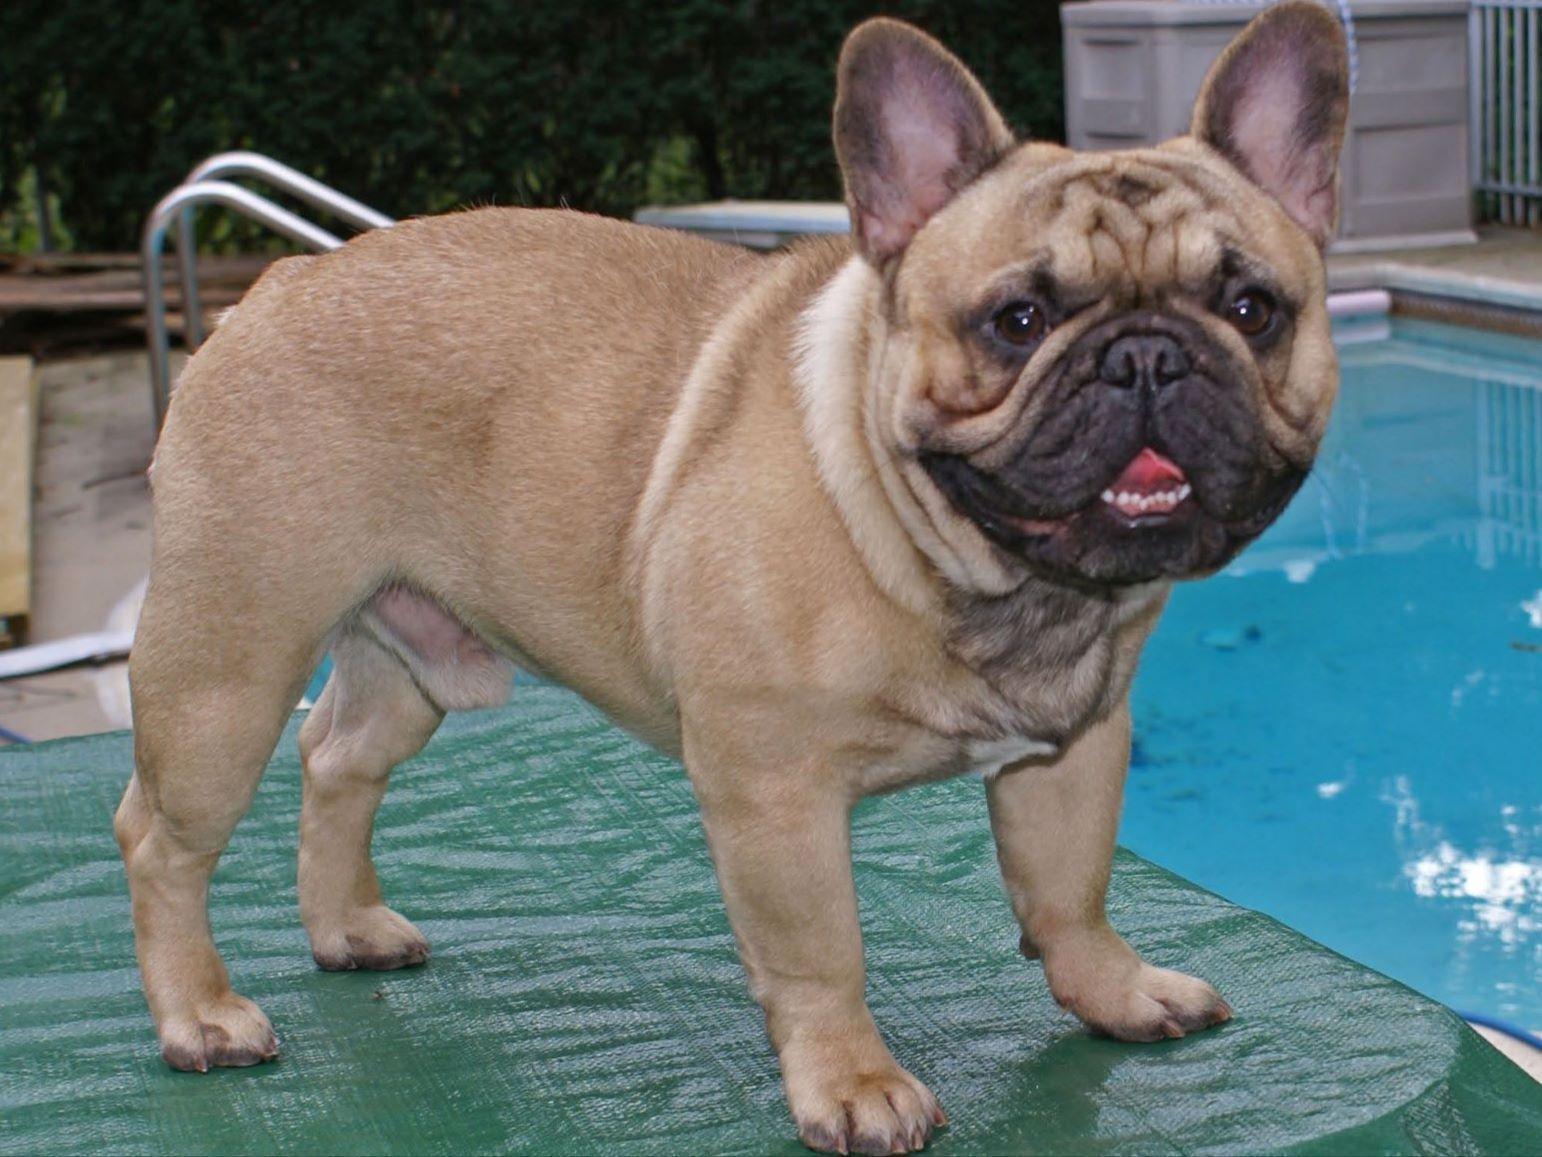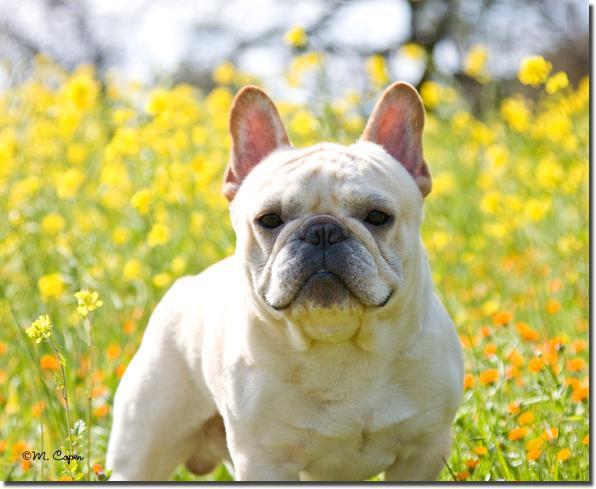The first image is the image on the left, the second image is the image on the right. For the images displayed, is the sentence "Two French Bulldogs are being held on a leash by a human." factually correct? Answer yes or no. No. The first image is the image on the left, the second image is the image on the right. Given the left and right images, does the statement "The left image features one standing buff-beige bulldog, and the right image contains one standing white bulldog who is gazing at the camera." hold true? Answer yes or no. Yes. 